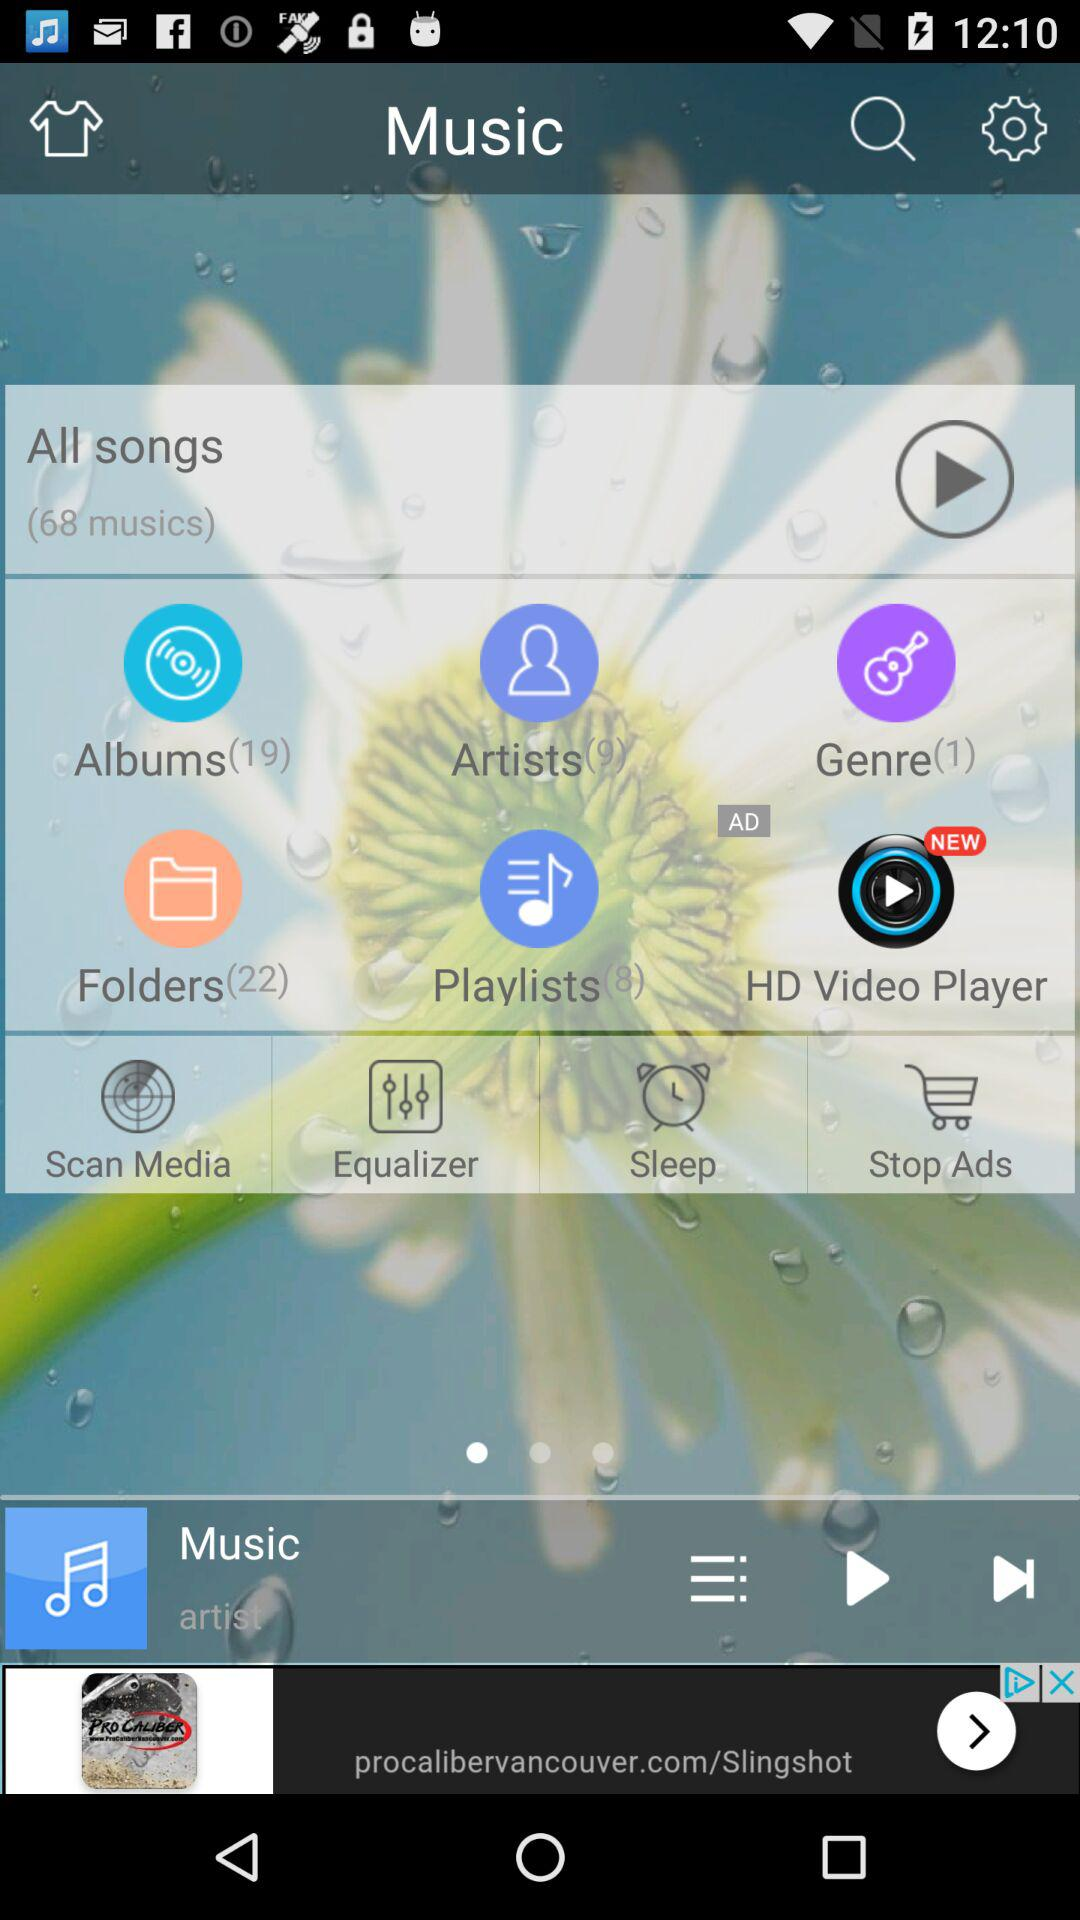What is the number of "All songs"? The number of "All songs" is 68. 